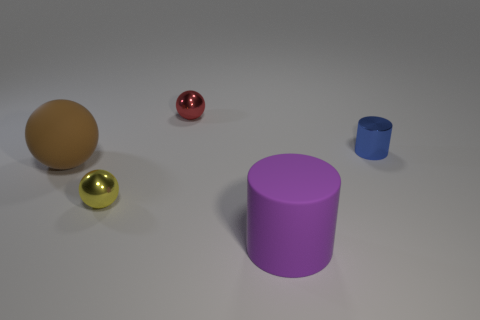There is a large object that is in front of the large brown ball; what is its shape?
Offer a terse response. Cylinder. What color is the large cylinder?
Offer a very short reply. Purple. There is a brown rubber sphere; is its size the same as the shiny sphere behind the blue cylinder?
Give a very brief answer. No. What number of matte objects are either purple objects or tiny yellow cylinders?
Give a very brief answer. 1. The blue object has what shape?
Ensure brevity in your answer.  Cylinder. There is a rubber object that is left of the rubber object that is in front of the large matte object behind the large purple cylinder; what is its size?
Provide a succinct answer. Large. What number of other things are the same shape as the blue object?
Your answer should be compact. 1. Is the shape of the tiny shiny thing that is in front of the tiny blue object the same as the large brown thing that is behind the yellow object?
Offer a very short reply. Yes. What number of spheres are either small red objects or large brown rubber things?
Make the answer very short. 2. There is a large sphere behind the metallic object that is in front of the big thing that is on the left side of the tiny yellow thing; what is its material?
Give a very brief answer. Rubber. 